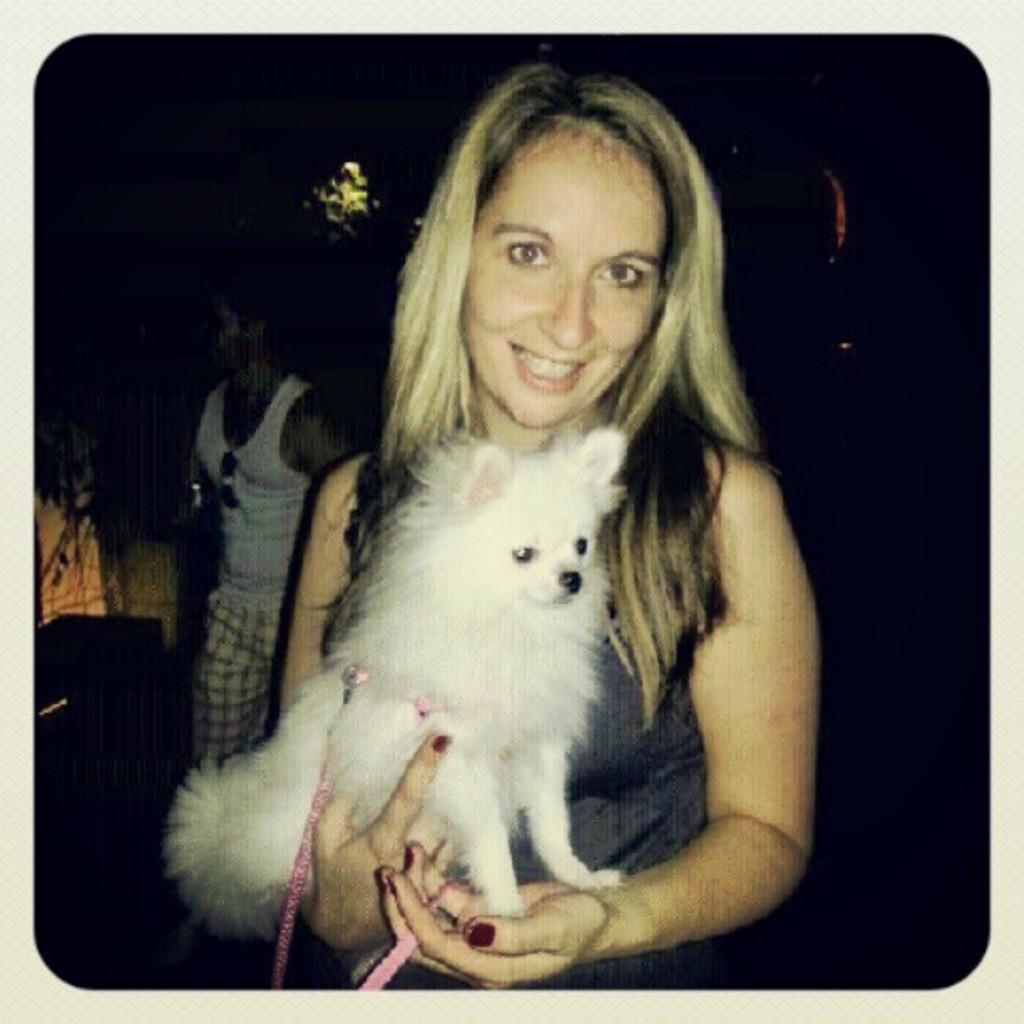Who is the main subject in the image? There is a woman in the center of the image. What is the woman doing in the image? The woman is smiling and holding a puppy. Is there anyone else in the image besides the woman with the puppy? Yes, there is another person beside the woman holding the puppy. What type of yarn is the woman using to create a boundary around the stage in the image? There is no yarn, boundary, or stage present in the image. 